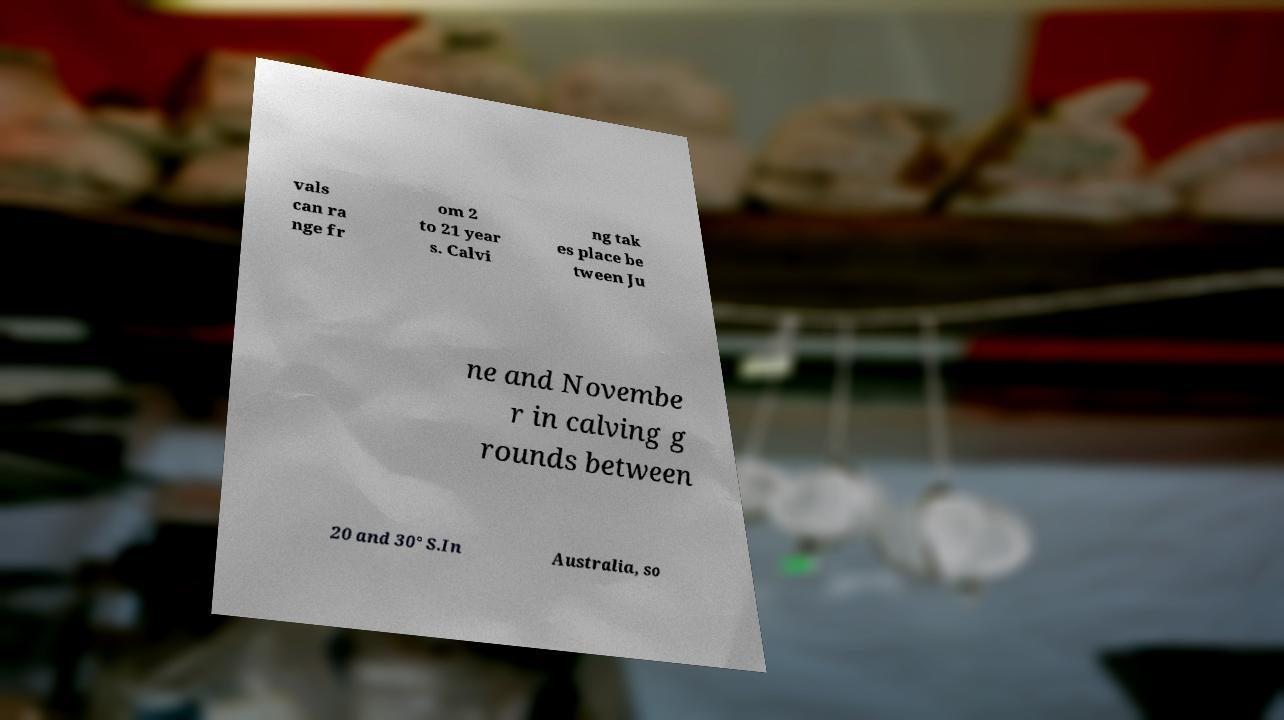Can you accurately transcribe the text from the provided image for me? vals can ra nge fr om 2 to 21 year s. Calvi ng tak es place be tween Ju ne and Novembe r in calving g rounds between 20 and 30° S.In Australia, so 